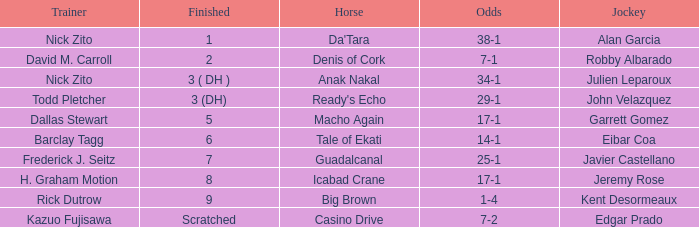What are the Odds for Trainer Barclay Tagg? 14-1. 